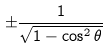Convert formula to latex. <formula><loc_0><loc_0><loc_500><loc_500>\pm { \frac { 1 } { \sqrt { 1 - \cos ^ { 2 } \theta } } }</formula> 